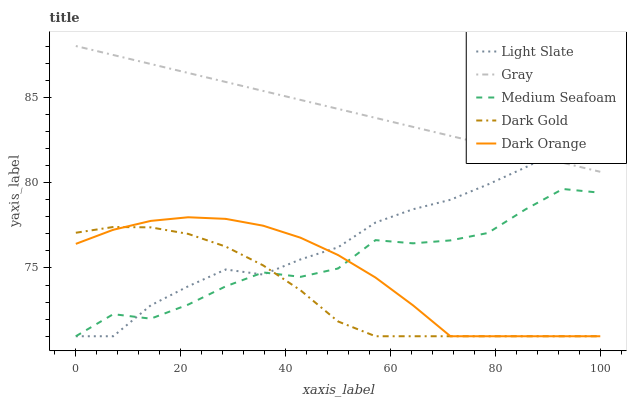Does Dark Gold have the minimum area under the curve?
Answer yes or no. Yes. Does Gray have the maximum area under the curve?
Answer yes or no. Yes. Does Medium Seafoam have the minimum area under the curve?
Answer yes or no. No. Does Medium Seafoam have the maximum area under the curve?
Answer yes or no. No. Is Gray the smoothest?
Answer yes or no. Yes. Is Medium Seafoam the roughest?
Answer yes or no. Yes. Is Medium Seafoam the smoothest?
Answer yes or no. No. Is Gray the roughest?
Answer yes or no. No. Does Light Slate have the lowest value?
Answer yes or no. Yes. Does Gray have the lowest value?
Answer yes or no. No. Does Gray have the highest value?
Answer yes or no. Yes. Does Medium Seafoam have the highest value?
Answer yes or no. No. Is Medium Seafoam less than Gray?
Answer yes or no. Yes. Is Gray greater than Medium Seafoam?
Answer yes or no. Yes. Does Dark Orange intersect Medium Seafoam?
Answer yes or no. Yes. Is Dark Orange less than Medium Seafoam?
Answer yes or no. No. Is Dark Orange greater than Medium Seafoam?
Answer yes or no. No. Does Medium Seafoam intersect Gray?
Answer yes or no. No. 